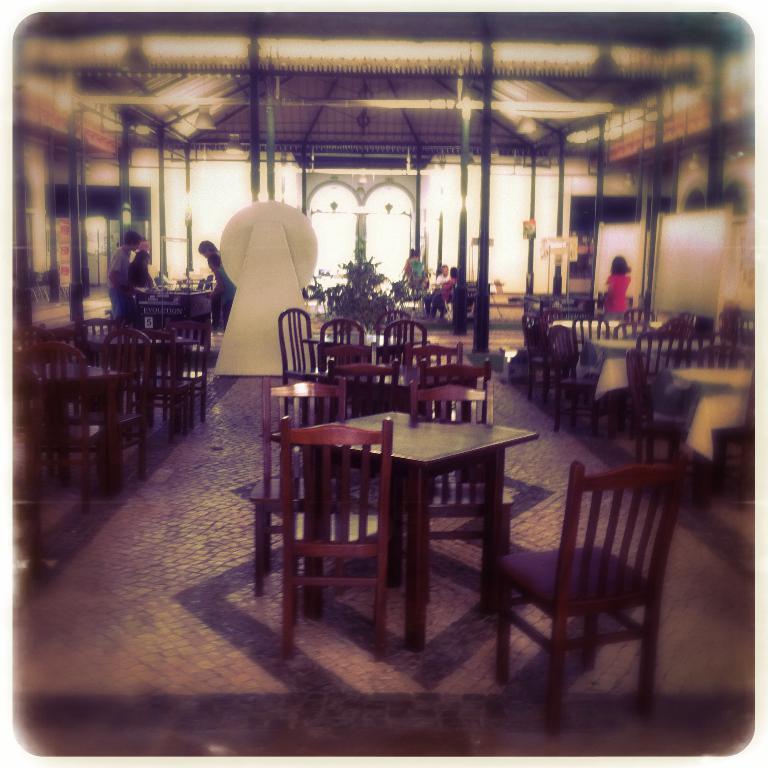How would you summarize this image in a sentence or two? In this picture we can see some people are sitting and some people are standing. In front of the people there are tables and chairs. Behind the tables there is a houseplant, pillars and boards. 